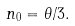Convert formula to latex. <formula><loc_0><loc_0><loc_500><loc_500>n _ { 0 } = \theta / 3 .</formula> 